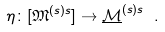Convert formula to latex. <formula><loc_0><loc_0><loc_500><loc_500>\eta \colon [ \mathfrak { M } ^ { ( s ) s } ] \to \underline { \mathcal { M } } ^ { ( s ) s } \ .</formula> 